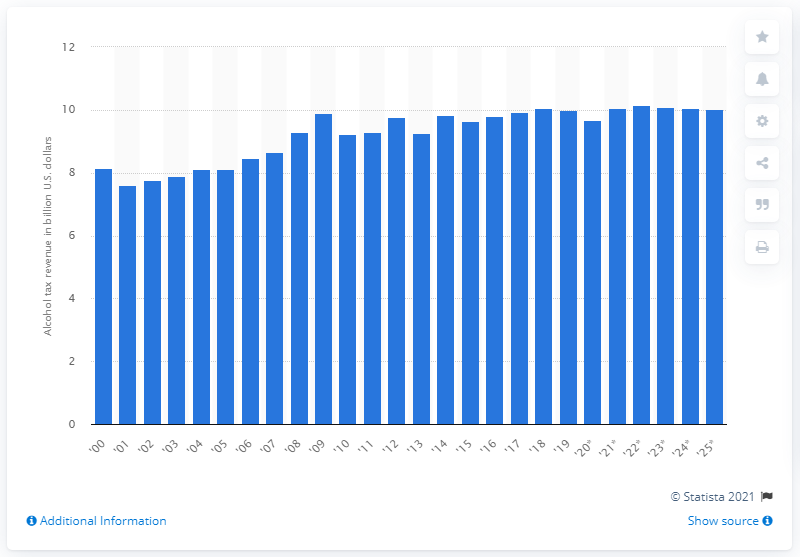Highlight a few significant elements in this photo. The projected increase in alcohol tax revenue in 2025 is expected to be 10.02. The alcohol tax revenue in the United States in 2019 was 10.02 billion dollars. 